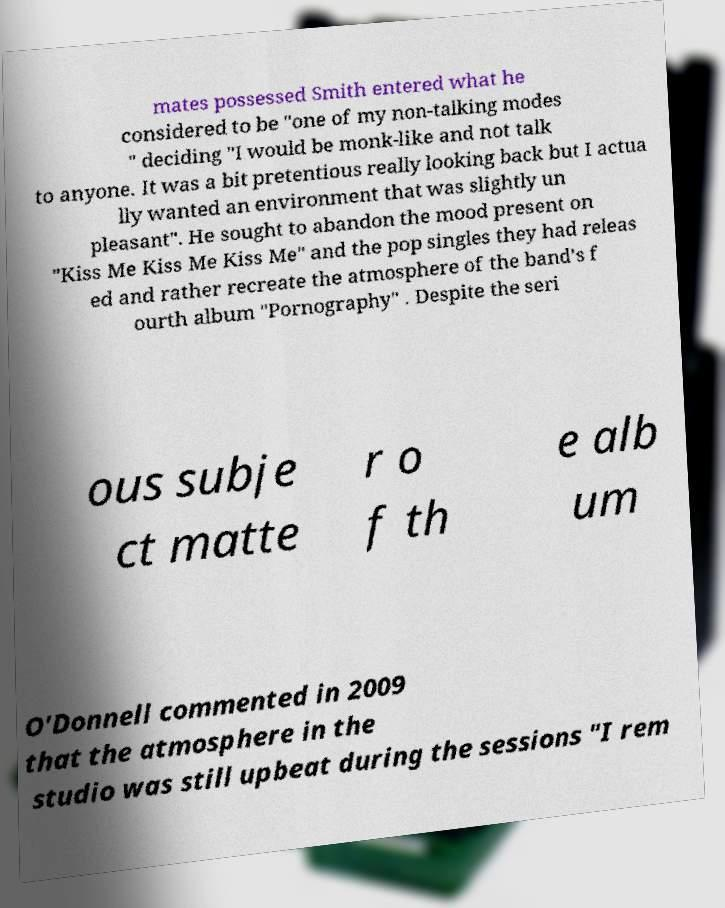Please identify and transcribe the text found in this image. mates possessed Smith entered what he considered to be "one of my non-talking modes " deciding "I would be monk-like and not talk to anyone. It was a bit pretentious really looking back but I actua lly wanted an environment that was slightly un pleasant". He sought to abandon the mood present on "Kiss Me Kiss Me Kiss Me" and the pop singles they had releas ed and rather recreate the atmosphere of the band's f ourth album "Pornography" . Despite the seri ous subje ct matte r o f th e alb um O'Donnell commented in 2009 that the atmosphere in the studio was still upbeat during the sessions "I rem 